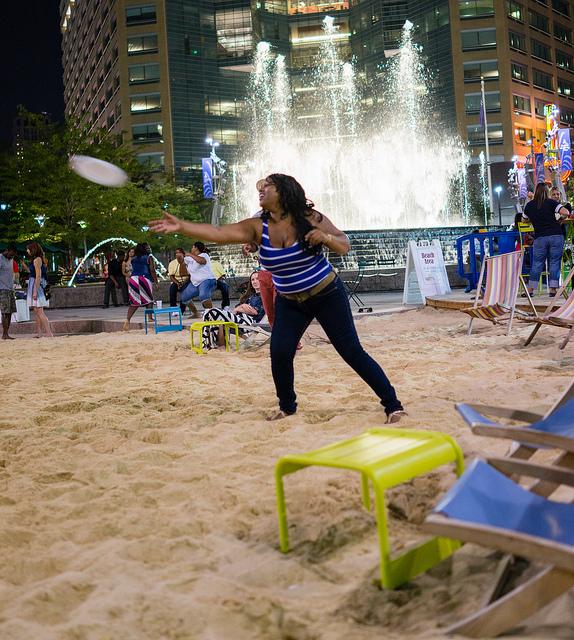How many women are playing a sport?
Quick response, please. 1. Is the woman skinny?
Short answer required. No. Is the woman catching or throwing the frisbee?
Write a very short answer. Throwing. 